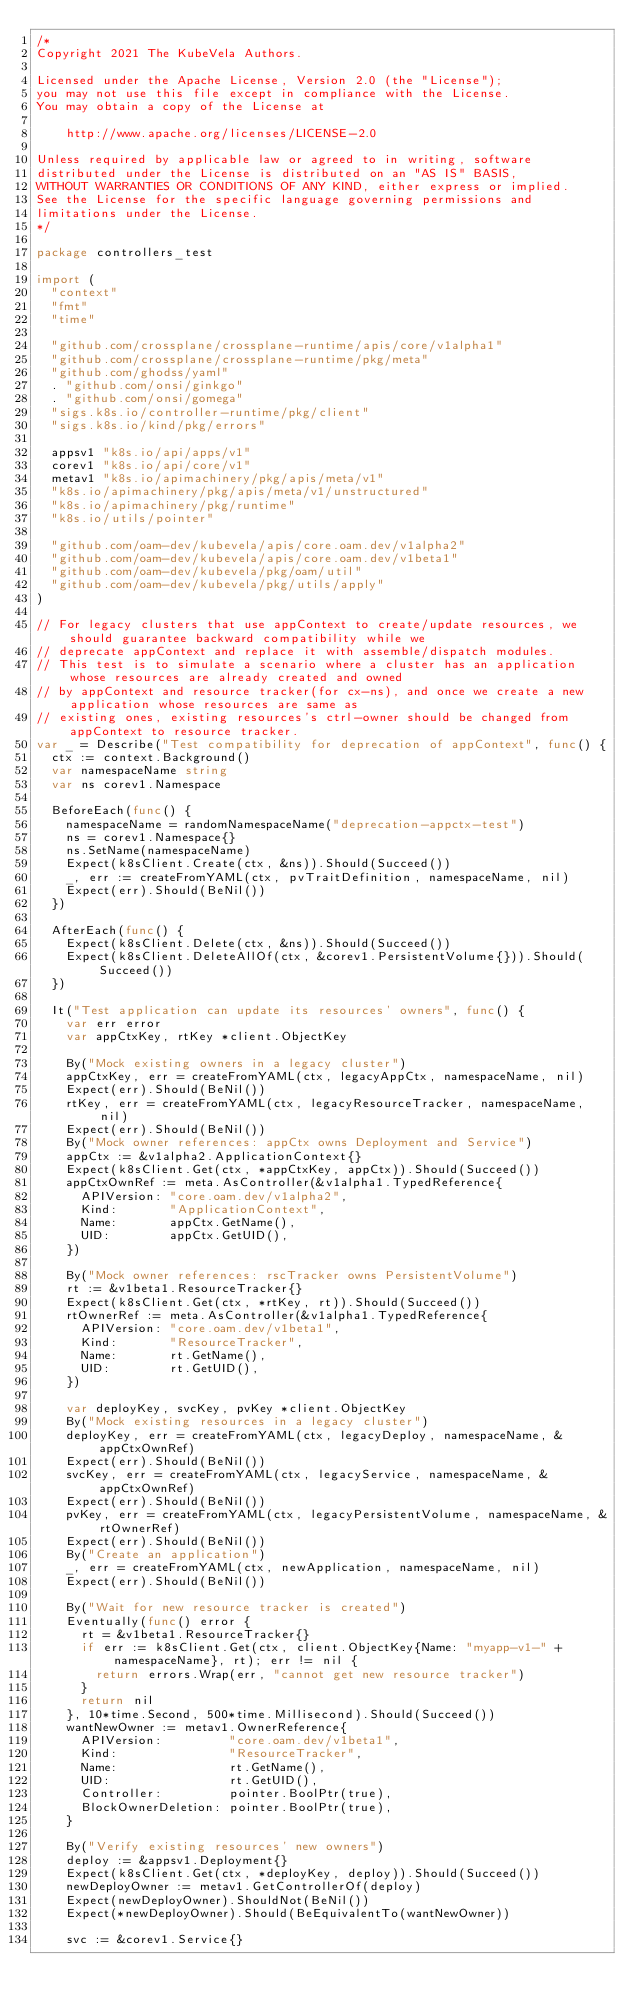<code> <loc_0><loc_0><loc_500><loc_500><_Go_>/*
Copyright 2021 The KubeVela Authors.

Licensed under the Apache License, Version 2.0 (the "License");
you may not use this file except in compliance with the License.
You may obtain a copy of the License at

    http://www.apache.org/licenses/LICENSE-2.0

Unless required by applicable law or agreed to in writing, software
distributed under the License is distributed on an "AS IS" BASIS,
WITHOUT WARRANTIES OR CONDITIONS OF ANY KIND, either express or implied.
See the License for the specific language governing permissions and
limitations under the License.
*/

package controllers_test

import (
	"context"
	"fmt"
	"time"

	"github.com/crossplane/crossplane-runtime/apis/core/v1alpha1"
	"github.com/crossplane/crossplane-runtime/pkg/meta"
	"github.com/ghodss/yaml"
	. "github.com/onsi/ginkgo"
	. "github.com/onsi/gomega"
	"sigs.k8s.io/controller-runtime/pkg/client"
	"sigs.k8s.io/kind/pkg/errors"

	appsv1 "k8s.io/api/apps/v1"
	corev1 "k8s.io/api/core/v1"
	metav1 "k8s.io/apimachinery/pkg/apis/meta/v1"
	"k8s.io/apimachinery/pkg/apis/meta/v1/unstructured"
	"k8s.io/apimachinery/pkg/runtime"
	"k8s.io/utils/pointer"

	"github.com/oam-dev/kubevela/apis/core.oam.dev/v1alpha2"
	"github.com/oam-dev/kubevela/apis/core.oam.dev/v1beta1"
	"github.com/oam-dev/kubevela/pkg/oam/util"
	"github.com/oam-dev/kubevela/pkg/utils/apply"
)

// For legacy clusters that use appContext to create/update resources, we should guarantee backward compatibility while we
// deprecate appContext and replace it with assemble/dispatch modules.
// This test is to simulate a scenario where a cluster has an application whose resources are already created and owned
// by appContext and resource tracker(for cx-ns), and once we create a new application whose resources are same as
// existing ones, existing resources's ctrl-owner should be changed from appContext to resource tracker.
var _ = Describe("Test compatibility for deprecation of appContext", func() {
	ctx := context.Background()
	var namespaceName string
	var ns corev1.Namespace

	BeforeEach(func() {
		namespaceName = randomNamespaceName("deprecation-appctx-test")
		ns = corev1.Namespace{}
		ns.SetName(namespaceName)
		Expect(k8sClient.Create(ctx, &ns)).Should(Succeed())
		_, err := createFromYAML(ctx, pvTraitDefinition, namespaceName, nil)
		Expect(err).Should(BeNil())
	})

	AfterEach(func() {
		Expect(k8sClient.Delete(ctx, &ns)).Should(Succeed())
		Expect(k8sClient.DeleteAllOf(ctx, &corev1.PersistentVolume{})).Should(Succeed())
	})

	It("Test application can update its resources' owners", func() {
		var err error
		var appCtxKey, rtKey *client.ObjectKey

		By("Mock existing owners in a legacy cluster")
		appCtxKey, err = createFromYAML(ctx, legacyAppCtx, namespaceName, nil)
		Expect(err).Should(BeNil())
		rtKey, err = createFromYAML(ctx, legacyResourceTracker, namespaceName, nil)
		Expect(err).Should(BeNil())
		By("Mock owner references: appCtx owns Deployment and Service")
		appCtx := &v1alpha2.ApplicationContext{}
		Expect(k8sClient.Get(ctx, *appCtxKey, appCtx)).Should(Succeed())
		appCtxOwnRef := meta.AsController(&v1alpha1.TypedReference{
			APIVersion: "core.oam.dev/v1alpha2",
			Kind:       "ApplicationContext",
			Name:       appCtx.GetName(),
			UID:        appCtx.GetUID(),
		})

		By("Mock owner references: rscTracker owns PersistentVolume")
		rt := &v1beta1.ResourceTracker{}
		Expect(k8sClient.Get(ctx, *rtKey, rt)).Should(Succeed())
		rtOwnerRef := meta.AsController(&v1alpha1.TypedReference{
			APIVersion: "core.oam.dev/v1beta1",
			Kind:       "ResourceTracker",
			Name:       rt.GetName(),
			UID:        rt.GetUID(),
		})

		var deployKey, svcKey, pvKey *client.ObjectKey
		By("Mock existing resources in a legacy cluster")
		deployKey, err = createFromYAML(ctx, legacyDeploy, namespaceName, &appCtxOwnRef)
		Expect(err).Should(BeNil())
		svcKey, err = createFromYAML(ctx, legacyService, namespaceName, &appCtxOwnRef)
		Expect(err).Should(BeNil())
		pvKey, err = createFromYAML(ctx, legacyPersistentVolume, namespaceName, &rtOwnerRef)
		Expect(err).Should(BeNil())
		By("Create an application")
		_, err = createFromYAML(ctx, newApplication, namespaceName, nil)
		Expect(err).Should(BeNil())

		By("Wait for new resource tracker is created")
		Eventually(func() error {
			rt = &v1beta1.ResourceTracker{}
			if err := k8sClient.Get(ctx, client.ObjectKey{Name: "myapp-v1-" + namespaceName}, rt); err != nil {
				return errors.Wrap(err, "cannot get new resource tracker")
			}
			return nil
		}, 10*time.Second, 500*time.Millisecond).Should(Succeed())
		wantNewOwner := metav1.OwnerReference{
			APIVersion:         "core.oam.dev/v1beta1",
			Kind:               "ResourceTracker",
			Name:               rt.GetName(),
			UID:                rt.GetUID(),
			Controller:         pointer.BoolPtr(true),
			BlockOwnerDeletion: pointer.BoolPtr(true),
		}

		By("Verify existing resources' new owners")
		deploy := &appsv1.Deployment{}
		Expect(k8sClient.Get(ctx, *deployKey, deploy)).Should(Succeed())
		newDeployOwner := metav1.GetControllerOf(deploy)
		Expect(newDeployOwner).ShouldNot(BeNil())
		Expect(*newDeployOwner).Should(BeEquivalentTo(wantNewOwner))

		svc := &corev1.Service{}</code> 